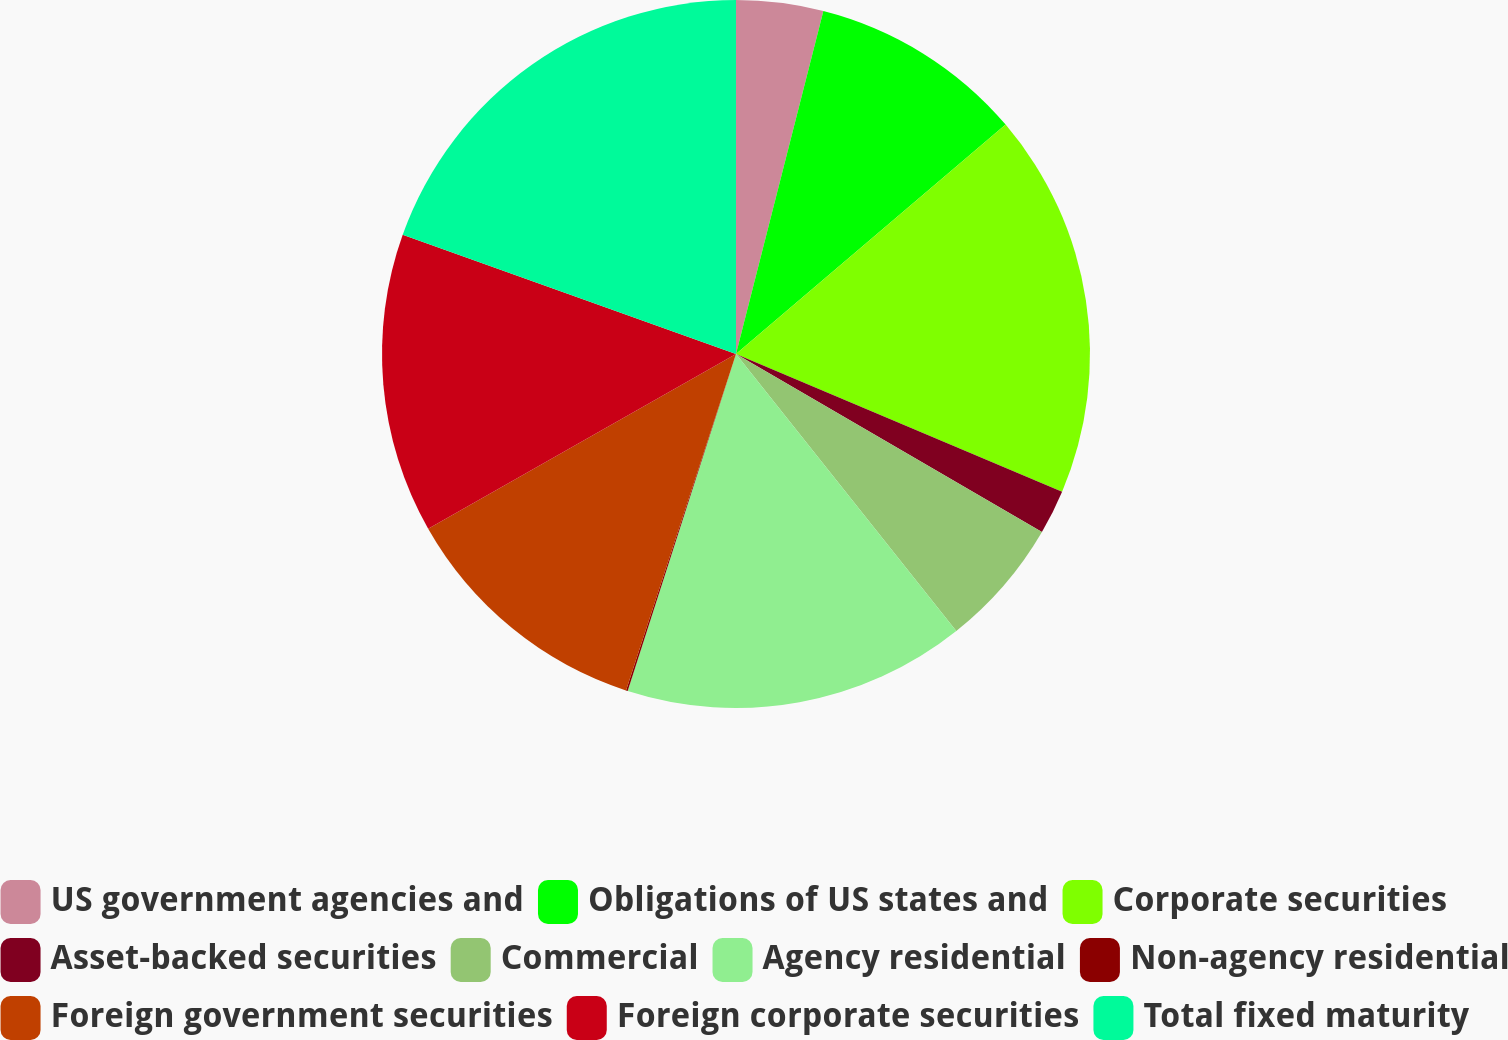Convert chart. <chart><loc_0><loc_0><loc_500><loc_500><pie_chart><fcel>US government agencies and<fcel>Obligations of US states and<fcel>Corporate securities<fcel>Asset-backed securities<fcel>Commercial<fcel>Agency residential<fcel>Non-agency residential<fcel>Foreign government securities<fcel>Foreign corporate securities<fcel>Total fixed maturity<nl><fcel>3.97%<fcel>9.81%<fcel>17.58%<fcel>2.03%<fcel>5.92%<fcel>15.64%<fcel>0.08%<fcel>11.75%<fcel>13.69%<fcel>19.53%<nl></chart> 